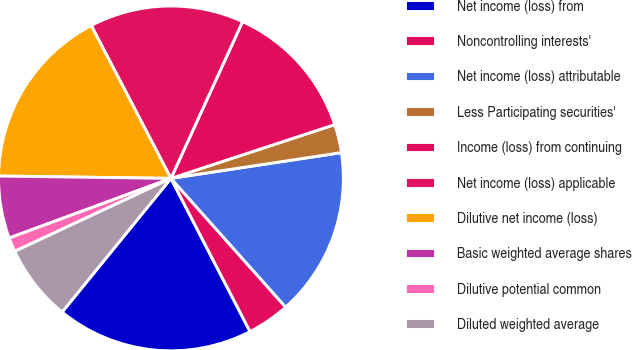<chart> <loc_0><loc_0><loc_500><loc_500><pie_chart><fcel>Net income (loss) from<fcel>Noncontrolling interests'<fcel>Net income (loss) attributable<fcel>Less Participating securities'<fcel>Income (loss) from continuing<fcel>Net income (loss) applicable<fcel>Dilutive net income (loss)<fcel>Basic weighted average shares<fcel>Dilutive potential common<fcel>Diluted weighted average<nl><fcel>18.46%<fcel>4.0%<fcel>15.8%<fcel>2.66%<fcel>13.13%<fcel>14.47%<fcel>17.13%<fcel>5.84%<fcel>1.33%<fcel>7.17%<nl></chart> 